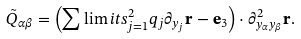Convert formula to latex. <formula><loc_0><loc_0><loc_500><loc_500>\tilde { Q } _ { \alpha \beta } = \left ( \sum \lim i t s _ { j = 1 } ^ { 2 } q _ { j } \partial _ { y _ { j } } \mathbf r - \mathbf e _ { 3 } \right ) \cdot \partial ^ { 2 } _ { y _ { \alpha } y _ { \beta } } \mathbf r .</formula> 